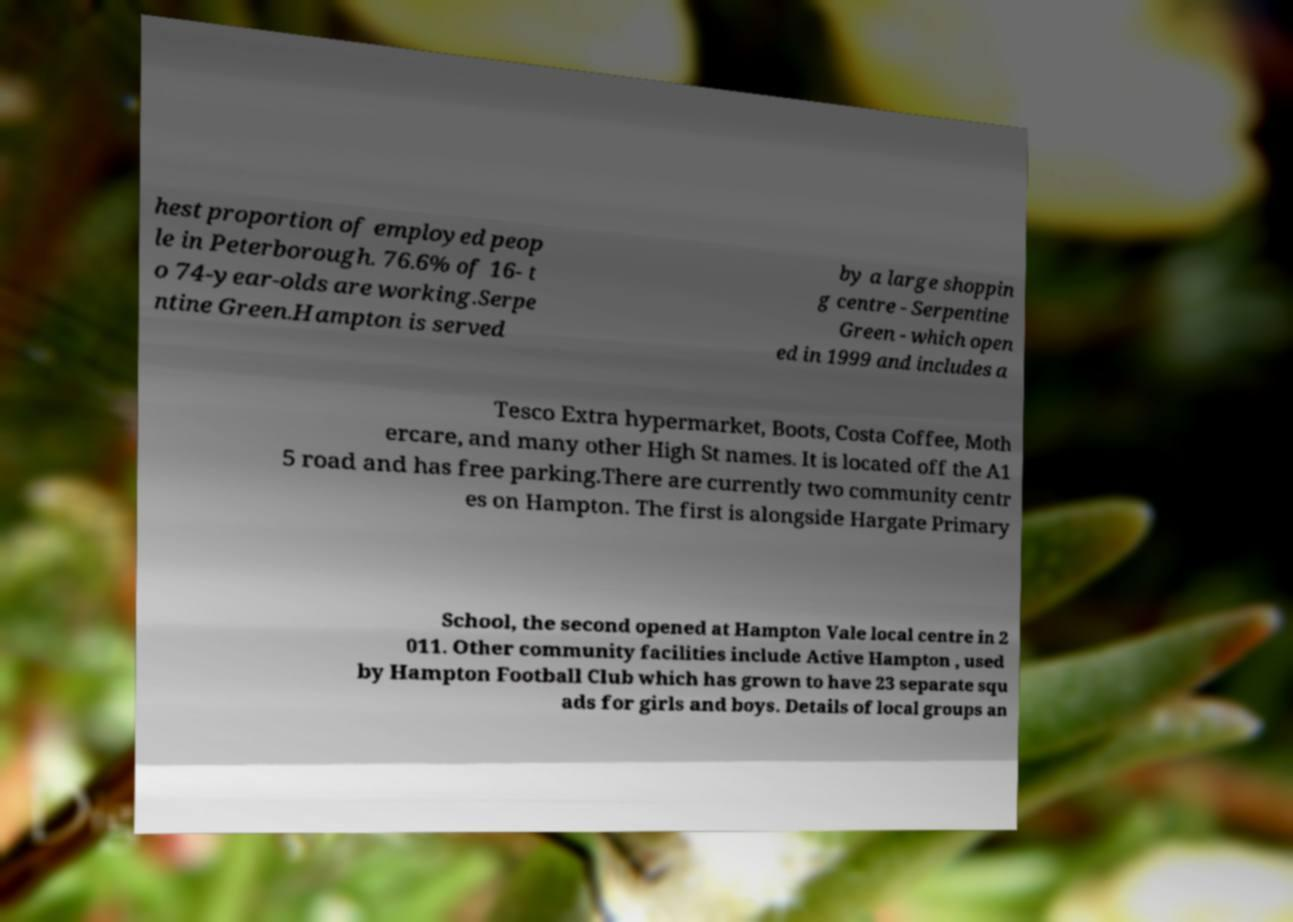What messages or text are displayed in this image? I need them in a readable, typed format. hest proportion of employed peop le in Peterborough. 76.6% of 16- t o 74-year-olds are working.Serpe ntine Green.Hampton is served by a large shoppin g centre - Serpentine Green - which open ed in 1999 and includes a Tesco Extra hypermarket, Boots, Costa Coffee, Moth ercare, and many other High St names. It is located off the A1 5 road and has free parking.There are currently two community centr es on Hampton. The first is alongside Hargate Primary School, the second opened at Hampton Vale local centre in 2 011. Other community facilities include Active Hampton , used by Hampton Football Club which has grown to have 23 separate squ ads for girls and boys. Details of local groups an 